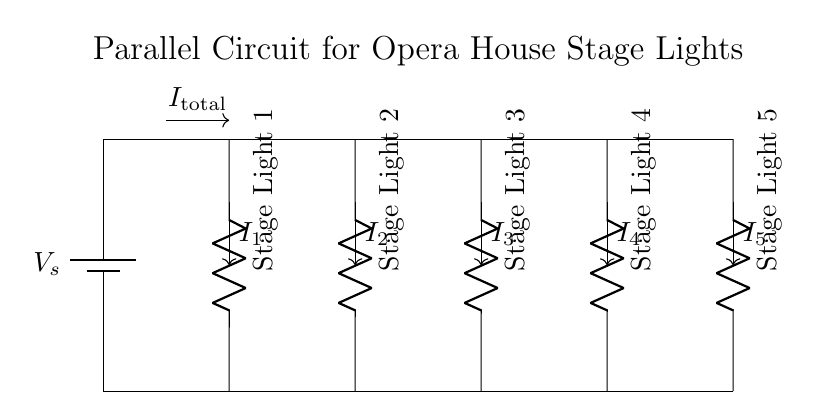What is the type of circuit shown? The circuit is a parallel circuit, as it has multiple branches that distribute power from a single source across different components. Each stage light is connected in parallel to the power supply.
Answer: Parallel circuit How many stage lights are connected? There are five stage lights indicated in the circuit diagram, each labeled sequentially from Stage Light 1 to Stage Light 5.
Answer: Five What is the total current flowing in the circuit? The total current, represented by the notation I_total, is the sum of the individual currents flowing through each light. The exact value isn't specified in the circuit; it’s a variable represented graphically.
Answer: I_total What is the role of the components in the circuit? Each component, labeled as Stage Light 1 to Stage Light 5, acts as a resistor that converts electrical energy into light, thereby illuminating the stage. All lights operate independently due to the parallel configuration.
Answer: Convert electricity to light If one stage light fails, what happens to the others? In a parallel circuit, if one component (stage light) fails, the other components remain functional because they have separate paths for current flow. This means the circuit continues to operate normally for the remaining lights.
Answer: They continue to work How is the current divided among the stage lights? The current divides among the stage lights based on their resistances according to the principles of a current divider. Each stage light will receive a fraction of the total current depending on its resistance relative to the others, allowing for independent brightness control.
Answer: Based on resistance 